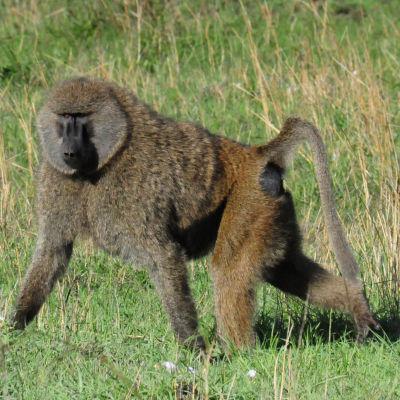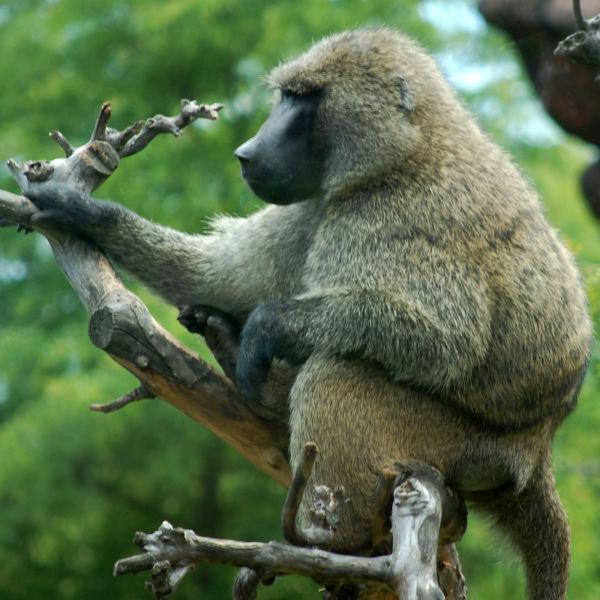The first image is the image on the left, the second image is the image on the right. Examine the images to the left and right. Is the description "There are at least three baboons." accurate? Answer yes or no. No. The first image is the image on the left, the second image is the image on the right. Evaluate the accuracy of this statement regarding the images: "Each image contains a single baboon, and no baboon has a wide-open mouth.". Is it true? Answer yes or no. Yes. 